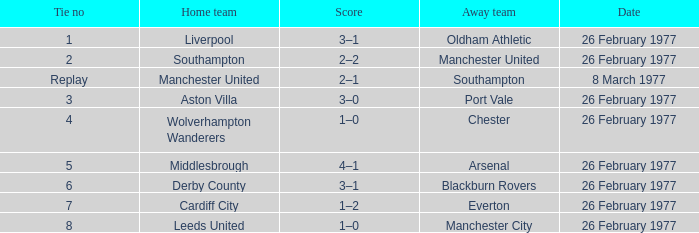What's the tally when the wolverhampton wanderers participated at home? 1–0. Parse the table in full. {'header': ['Tie no', 'Home team', 'Score', 'Away team', 'Date'], 'rows': [['1', 'Liverpool', '3–1', 'Oldham Athletic', '26 February 1977'], ['2', 'Southampton', '2–2', 'Manchester United', '26 February 1977'], ['Replay', 'Manchester United', '2–1', 'Southampton', '8 March 1977'], ['3', 'Aston Villa', '3–0', 'Port Vale', '26 February 1977'], ['4', 'Wolverhampton Wanderers', '1–0', 'Chester', '26 February 1977'], ['5', 'Middlesbrough', '4–1', 'Arsenal', '26 February 1977'], ['6', 'Derby County', '3–1', 'Blackburn Rovers', '26 February 1977'], ['7', 'Cardiff City', '1–2', 'Everton', '26 February 1977'], ['8', 'Leeds United', '1–0', 'Manchester City', '26 February 1977']]} 